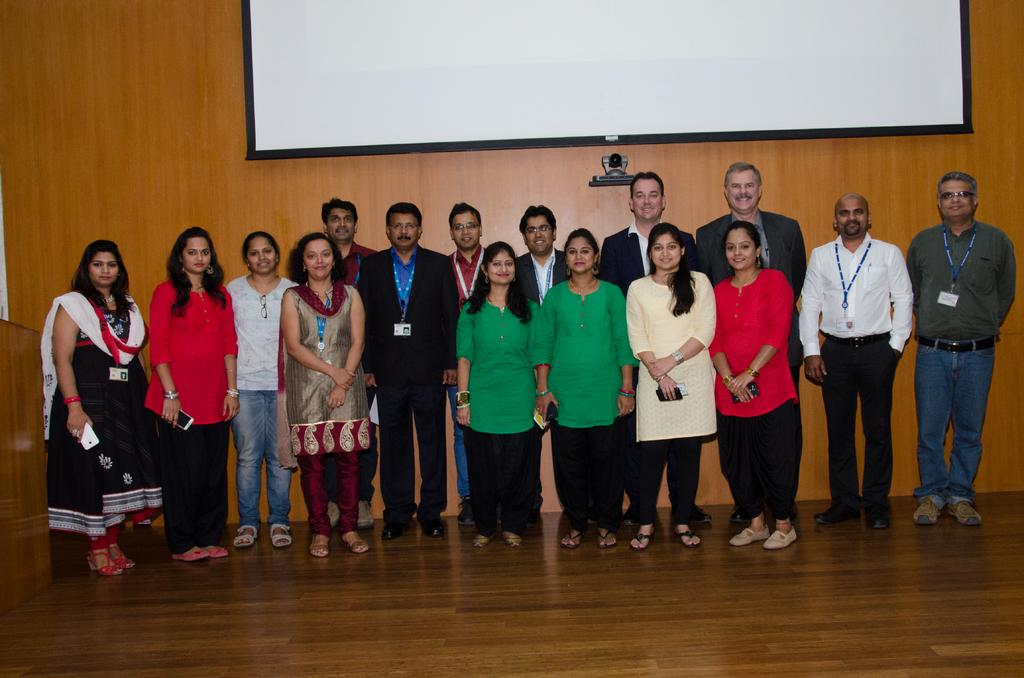How many people are present in the image? There are many people standing in the image. What are some people wearing in the image? Some people are wearing tags in the image. What are some people holding in the image? Some people are holding mobiles in the image. What can be seen in the background of the image? There is a wooden wall in the background of the image. What is on the wooden wall in the image? There is a screen and a camera on the wooden wall in the image. What type of balls are being thrown in the image? There are no balls present in the image. 